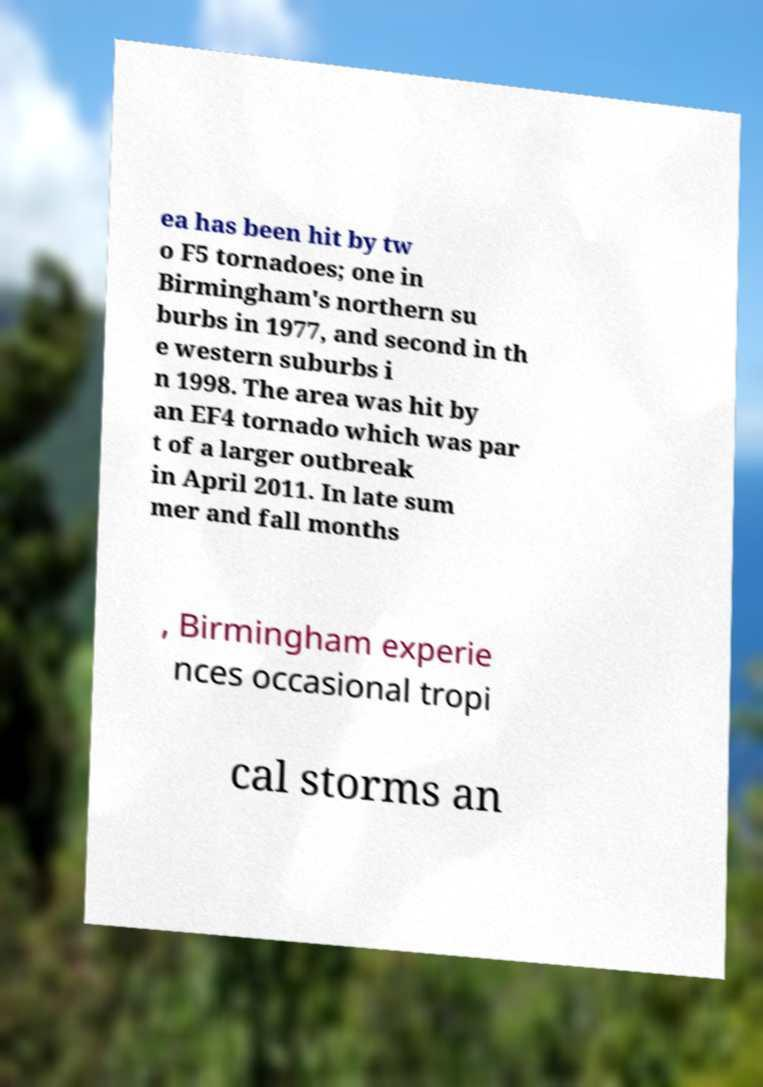Can you read and provide the text displayed in the image?This photo seems to have some interesting text. Can you extract and type it out for me? ea has been hit by tw o F5 tornadoes; one in Birmingham's northern su burbs in 1977, and second in th e western suburbs i n 1998. The area was hit by an EF4 tornado which was par t of a larger outbreak in April 2011. In late sum mer and fall months , Birmingham experie nces occasional tropi cal storms an 